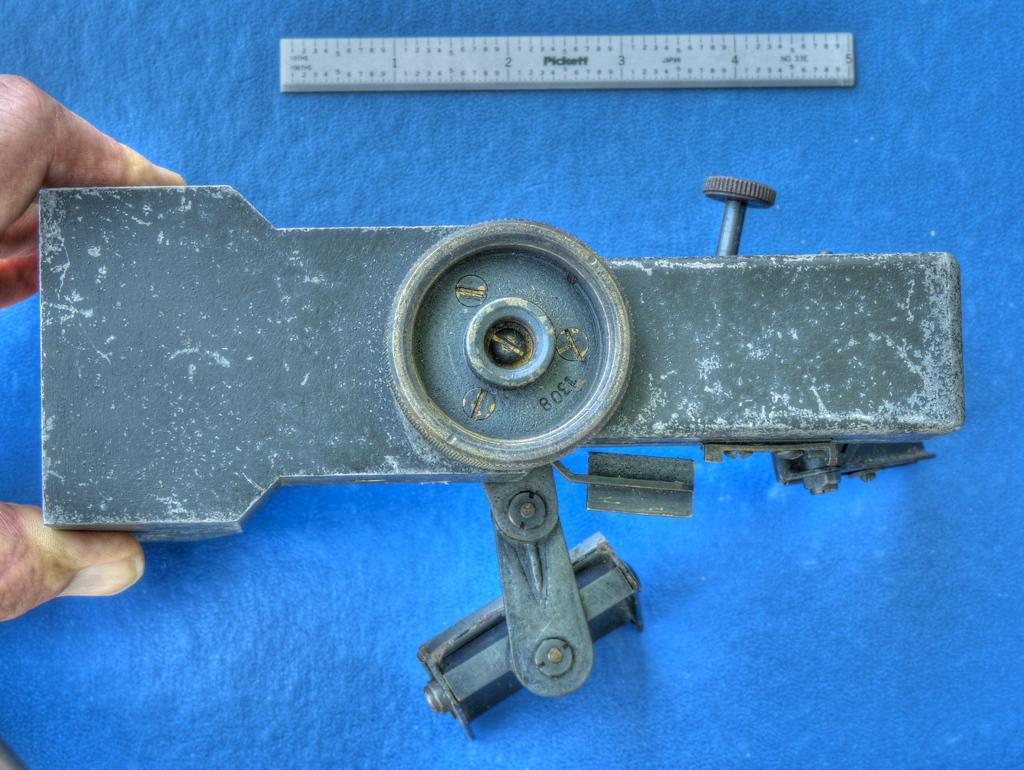What is the last number on the ruler?
Offer a terse response. 5. 